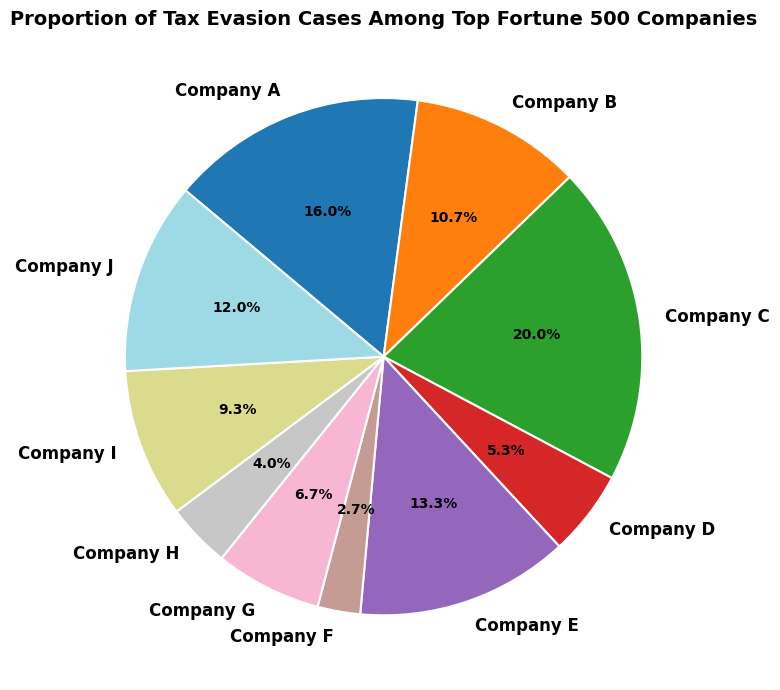Which company has the highest proportion of tax evasion cases? The company with the largest slice in the pie chart represents the highest proportion. We can see that Company C has the largest slice.
Answer: Company C Comparing Company A and Company E, which one has a higher proportion of tax evasion cases? By comparing the sizes of the slices representing Company A and Company E, Company A has a larger slice, indicating a higher proportion.
Answer: Company A Which company has the smallest proportion of tax evasion cases? The smallest slice in the pie chart represents the company with the lowest proportion of tax evasion cases. Company F has the smallest slice.
Answer: Company F How many more tax evasion cases does Company C have compared to Company B? Company C has 15 cases and Company B has 8 cases. Subtracting the number of cases for Company B from Company C: 15 - 8 = 7
Answer: 7 What is the combined proportion of tax evasion cases for Companies D, H, and F? Companies D, H, and F have 4, 3, and 2 cases respectively. Their combined cases = 4 + 3 + 2 = 9. To find the proportion, divide by the total number of cases (75) and multiply by 100: (9/75) * 100 = 12%
Answer: 12% Which company has just over 10% of the tax evasion cases? By looking at the slices annotated with percentages, Company E has 10%. Since it's close to but precisely matches the value, it's the correct answer.
Answer: Company E Does Company J have a higher or lower proportion of tax evasion cases compared to Company I? By comparing the slices, Company J has a larger slice than Company I, indicating a higher proportion.
Answer: Higher What’s the approximate average number of tax evasion cases across all companies? The total number of tax evasion cases is 75 (sum of all cases). There are 10 companies. The average number is found by dividing total cases by the number of companies: 75 / 10 = 7.5
Answer: 7.5 Which companies have a proportion of tax evasion cases close to 10%? Looking at the pie chart, Company E has a proportion exactly at 10%, while Company J, with 9 cases, also appears close in proportion.
Answer: Company E, Company J 